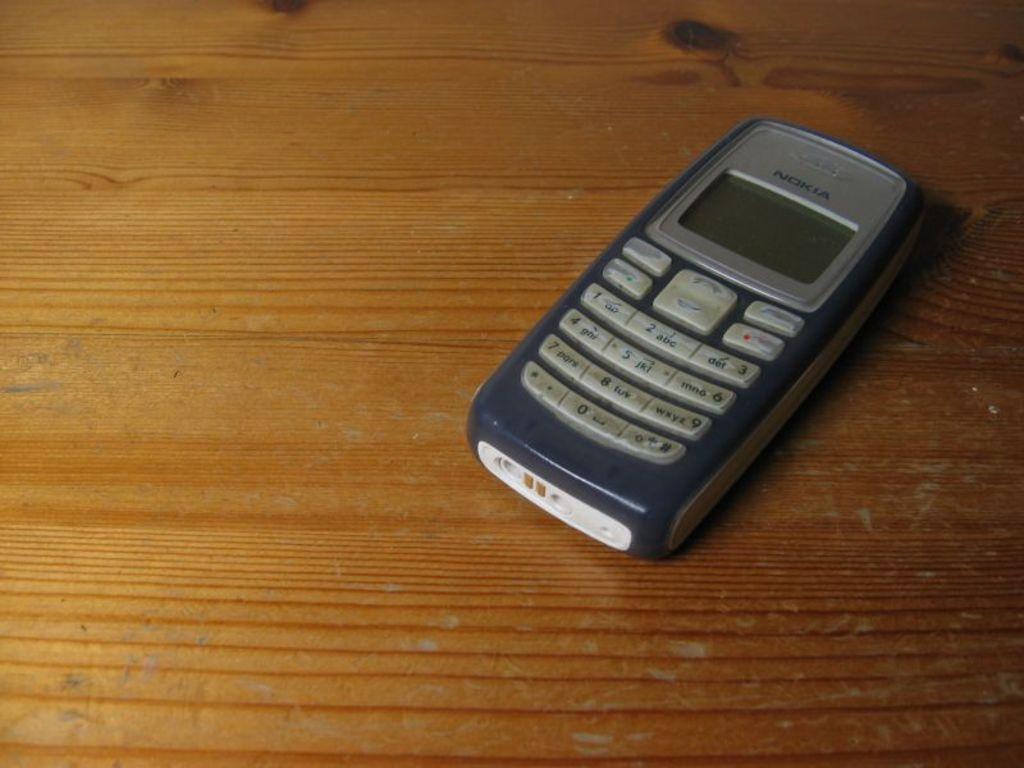What brand is the phone?
Offer a terse response. Nokia. 